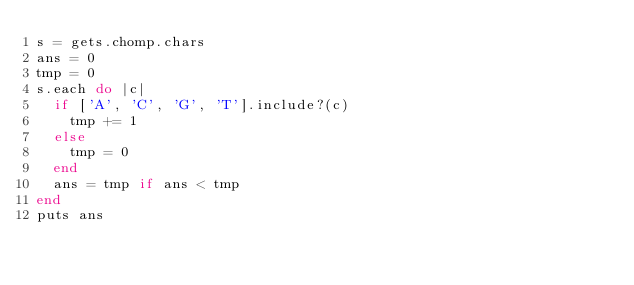Convert code to text. <code><loc_0><loc_0><loc_500><loc_500><_Ruby_>s = gets.chomp.chars
ans = 0
tmp = 0
s.each do |c|
  if ['A', 'C', 'G', 'T'].include?(c)
    tmp += 1
  else
    tmp = 0
  end
  ans = tmp if ans < tmp
end
puts ans</code> 